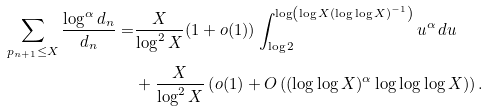Convert formula to latex. <formula><loc_0><loc_0><loc_500><loc_500>\sum _ { p _ { n + 1 } \leq X } \frac { \log ^ { \alpha } d _ { n } } { d _ { n } } = & \frac { X } { \log ^ { 2 } X } ( 1 + o ( 1 ) ) \int _ { \log 2 } ^ { \log \left ( \log X ( \log \log X ) ^ { - 1 } \right ) } u ^ { \alpha } \, d u \\ & + \frac { X } { \log ^ { 2 } X } \left ( o ( 1 ) + O \left ( ( \log \log X ) ^ { \alpha } \log \log \log X \right ) \right ) .</formula> 